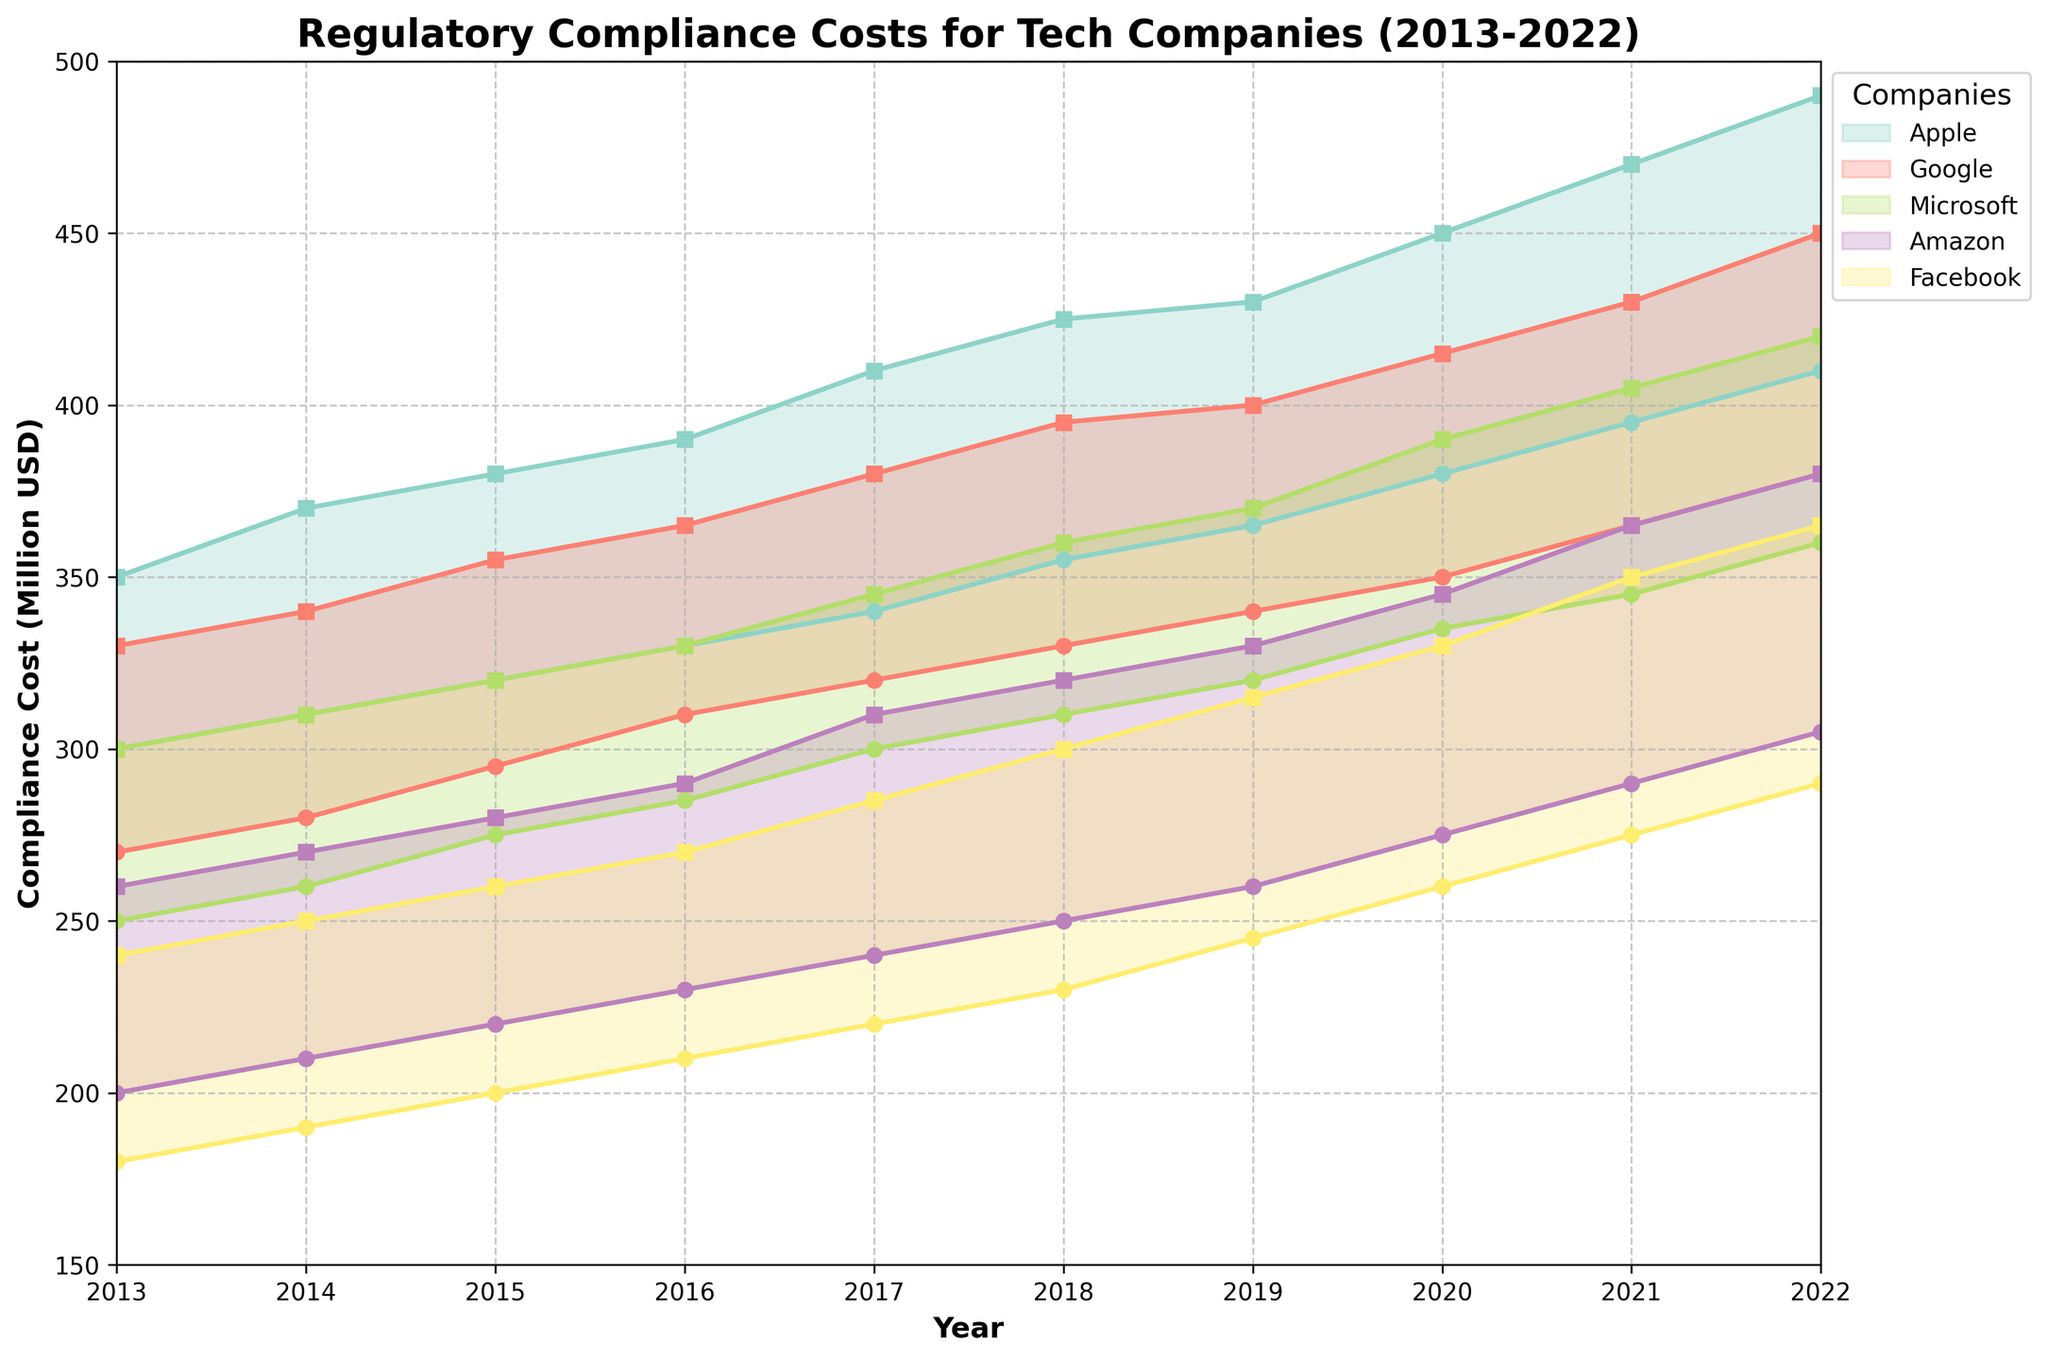What is the title of the figure? The title is the text located at the top of the figure. From the description, the title is "Regulatory Compliance Costs for Tech Companies (2013-2022)"
Answer: Regulatory Compliance Costs for Tech Companies (2013-2022) How many companies are represented in the figure? The figure represents unique companies as indicated by the legend entries. There are 5 entries in the legend, one for each company.
Answer: 5 What is the range of compliance costs for Google in 2016? For 2016 and Google, we look at the Y-values marked by the lower and upper edges of the shaded region. Min is 310 million USD and Max is 365 million USD.
Answer: 310-365 million USD Between which years did Amazon see an increase in its maximum compliance cost of at least 15 million USD? Compare the maximum compliance costs sequentially for Amazon. 
1. From 2014 to 2015: 270 million to 280 million USD.
2. From 2015 to 2016: 280 million to 290 million USD.
3. From 2019 to 2020: 330 million to 345 million USD.
4. From 2021 to 2022: 365 million to 380 million USD.
These show increases of at least 15 million USD.
Answer: 2014-2015, 2015-2016, 2019-2020, 2021-2022 Which company experienced the highest minimum compliance cost in 2021? Locate the 2021 data points and find the highest minimum compliance cost. Apple has a minimum compliance cost of 395 million USD, the highest among the companies.
Answer: Apple What was the average minimum compliance cost for Facebook over the decade? Sum the minimum compliance costs from 2013 to 2022 for Facebook and divide by 10:
(180 + 190 + 200 + 210 + 220 + 230 + 245 + 260 + 275 + 290) / 10 = 2300 / 10 = 230 million USD
Answer: 230 million USD Which two companies had the smallest range in compliance costs in 2019? Calculate the range for each company in 2019:
- Apple: 430 - 365 = 65
- Google: 400 - 340 = 60
- Microsoft: 370 - 320 = 50
- Amazon: 330 - 260 = 70
- Facebook: 315 - 245 = 70
The two smallest ranges are for Microsoft and Google.
Answer: Microsoft and Google Did Amazon or Facebook have a greater increase in minimum compliance cost from 2013 to 2022? Calculate the differences in minimum compliance cost from 2013 to 2022:
- Amazon: 305 - 200 = 105
- Facebook: 290 - 180 = 110
Facebook had a greater increase.
Answer: Facebook Over the past decade, which company saw the steepest increase in both minimum and maximum compliance costs? Look at the differences from 2013 to 2022 for both minimum and maximum costs for all companies:
- Apple: (490 - 350) + (410 - 300) = 140 + 110 = 250
- Google: (450 - 330) + (380 - 270) = 120 + 110 = 230
- Microsoft: (420 - 300) + (360 - 250) = 120 + 110 = 230
- Amazon: (380 - 260) + (305 - 200) = 120 + 105 = 225
- Facebook: (365 - 240) + (290 - 180) = 125 + 110 = 235
Apple had the steepest increase in compliance costs.
Answer: Apple 